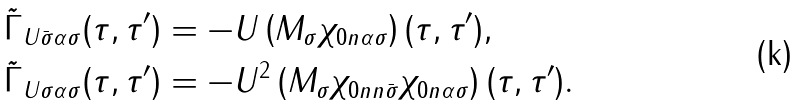Convert formula to latex. <formula><loc_0><loc_0><loc_500><loc_500>& \tilde { \Gamma } _ { U \bar { \sigma } \alpha \sigma } ( \tau , \tau ^ { \prime } ) = - U \left ( M _ { \sigma } \chi _ { 0 n \alpha \sigma } \right ) ( \tau , \tau ^ { \prime } ) , \\ & \tilde { \Gamma } _ { U \sigma \alpha \sigma } ( \tau , \tau ^ { \prime } ) = - U ^ { 2 } \left ( M _ { \sigma } \chi _ { 0 n n \bar { \sigma } } \chi _ { 0 n \alpha \sigma } \right ) ( \tau , \tau ^ { \prime } ) .</formula> 